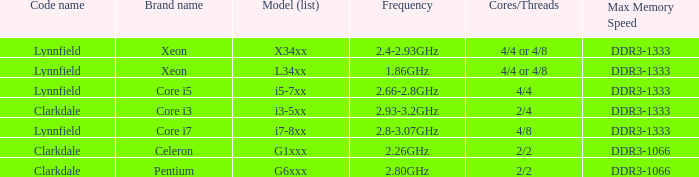What frequency does model L34xx use? 1.86GHz. 